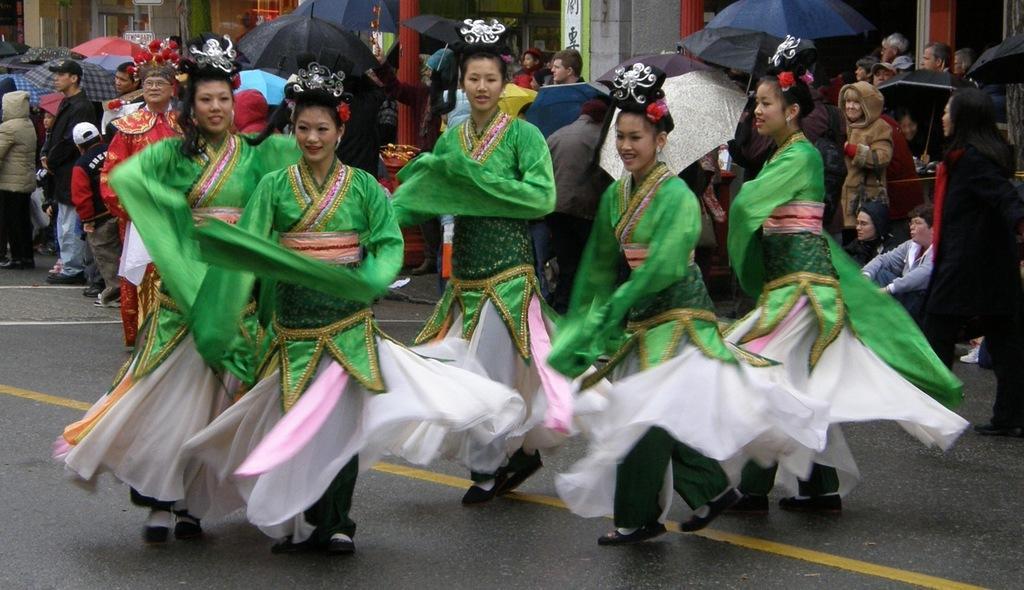Could you give a brief overview of what you see in this image? In this picture there are girls in the center of the image, they are wearing costumes, it seems to be they are dancing and there are other people those who are holding umbrellas in their hands and there are buildings in the background area of the image. 